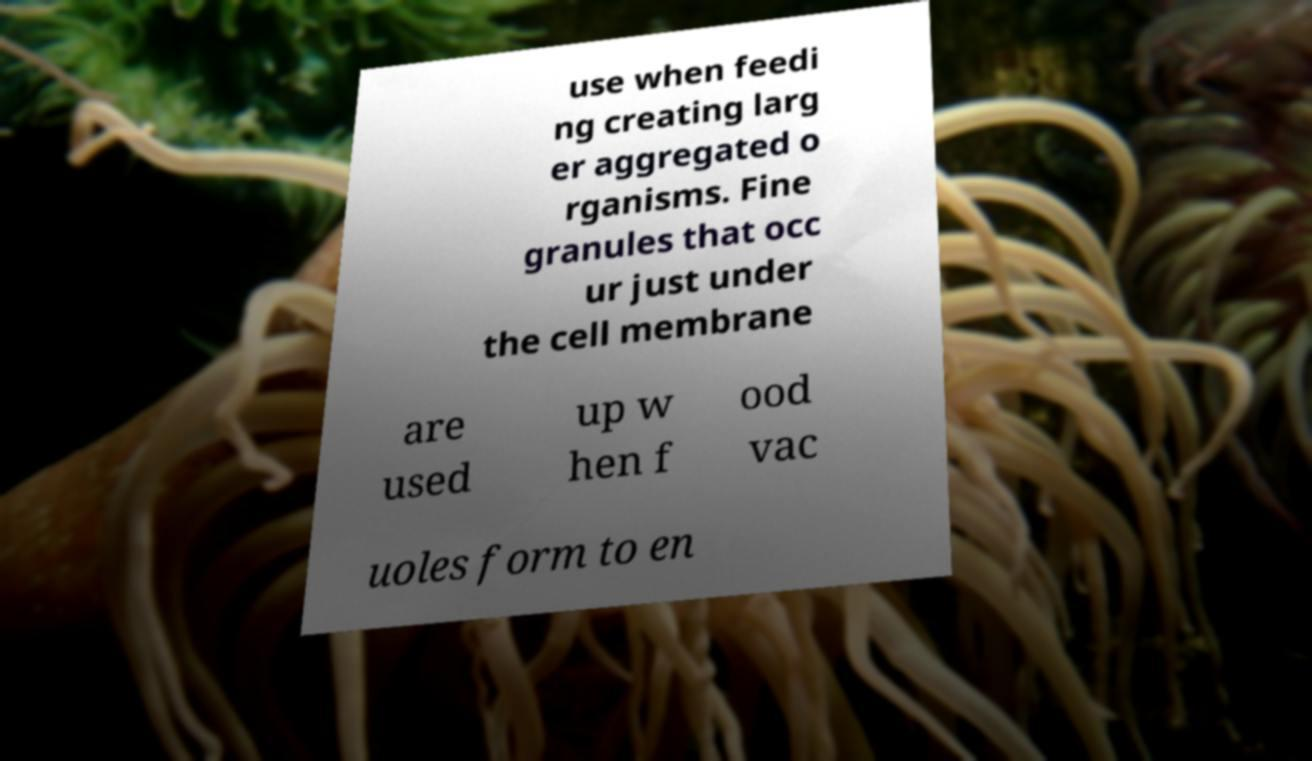Can you accurately transcribe the text from the provided image for me? use when feedi ng creating larg er aggregated o rganisms. Fine granules that occ ur just under the cell membrane are used up w hen f ood vac uoles form to en 